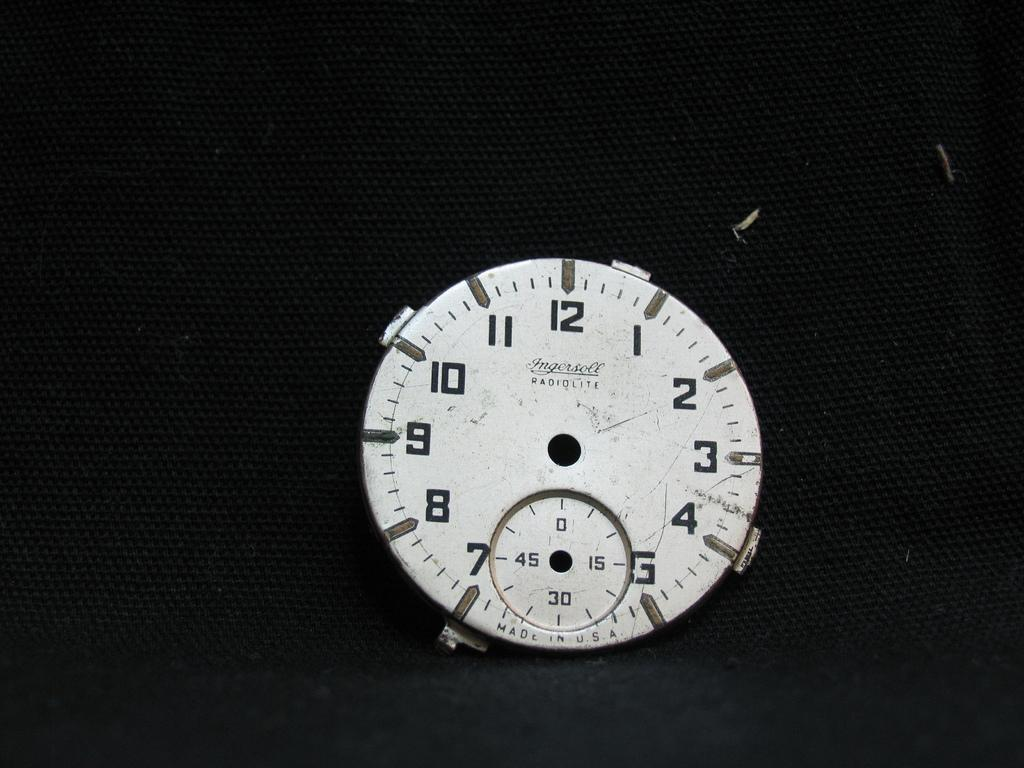<image>
Summarize the visual content of the image. A clock that says Ingersoll Radiolite does not have any hands on it. 